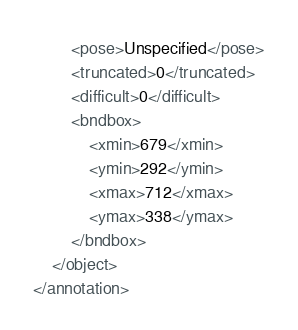<code> <loc_0><loc_0><loc_500><loc_500><_XML_>		<pose>Unspecified</pose>
		<truncated>0</truncated>
		<difficult>0</difficult>
		<bndbox>
			<xmin>679</xmin>
			<ymin>292</ymin>
			<xmax>712</xmax>
			<ymax>338</ymax>
		</bndbox>
	</object>
</annotation></code> 